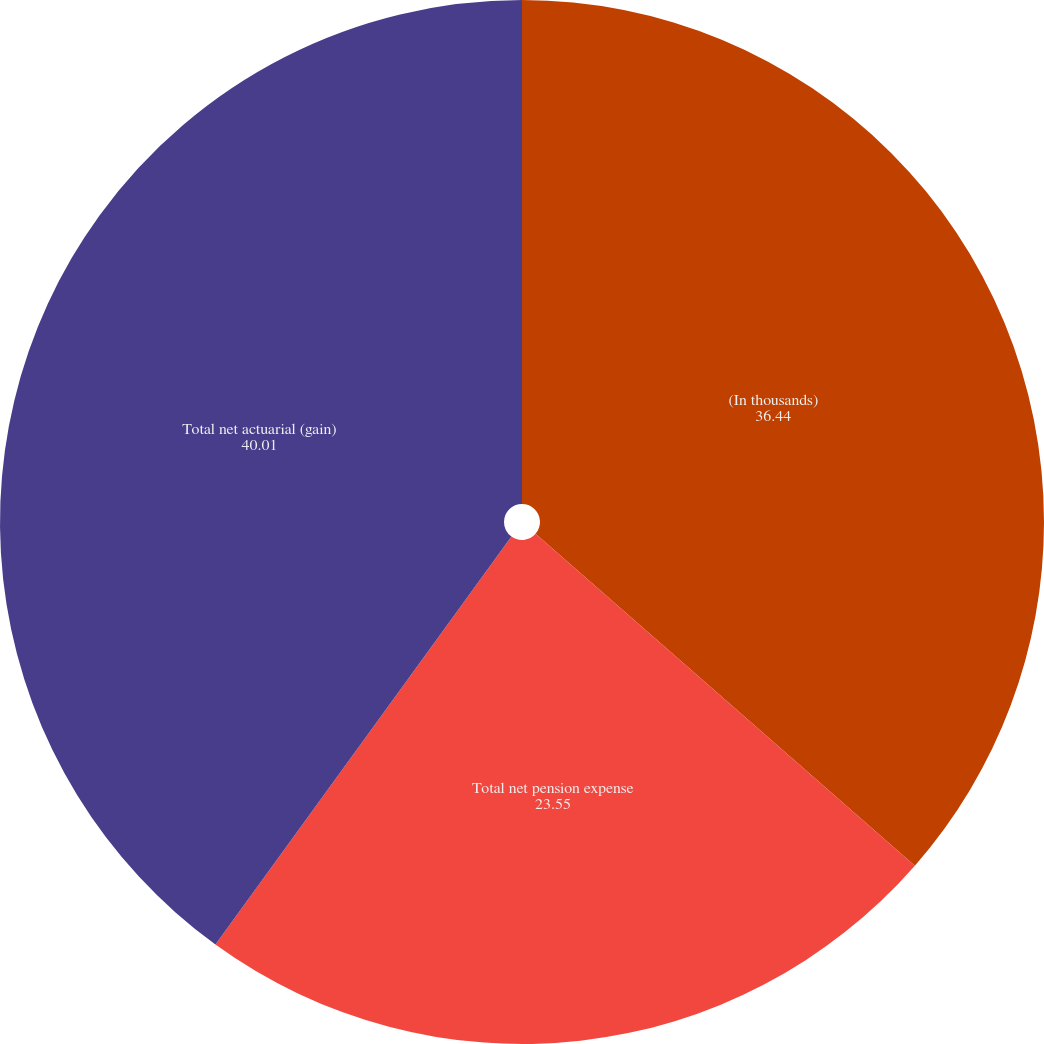Convert chart to OTSL. <chart><loc_0><loc_0><loc_500><loc_500><pie_chart><fcel>(In thousands)<fcel>Total net pension expense<fcel>Total net actuarial (gain)<nl><fcel>36.44%<fcel>23.55%<fcel>40.01%<nl></chart> 